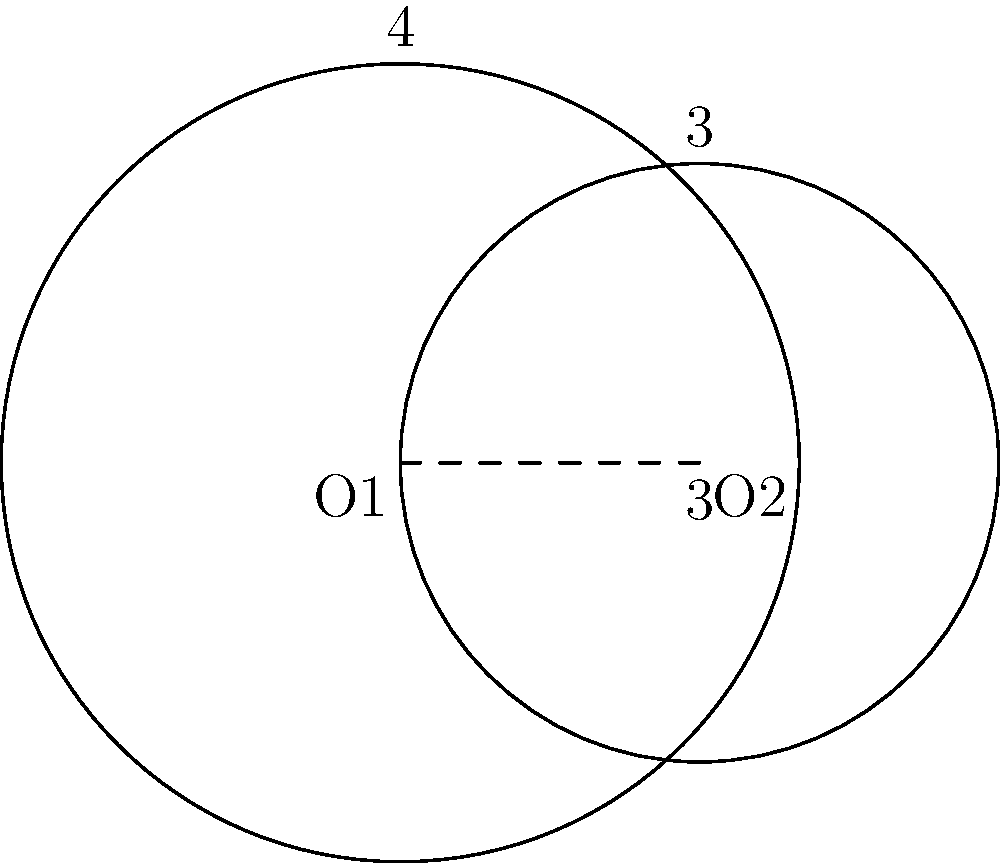As a software engineer working on a vehicle tracking system, you encounter a problem involving overlapping circular Wi-Fi ranges. Two Wi-Fi hotspots are represented by intersecting circles with centers O1 and O2. The distance between the centers is 3 units. The radius of the circle centered at O1 is 4 units, and the radius of the circle centered at O2 is 3 units. Calculate the area of the region where the two Wi-Fi ranges overlap (i.e., the area of the lens-shaped region formed by the intersection of the two circles). Let's approach this step-by-step:

1) First, we need to find the angle θ at the center of each circle in the overlapping region. We can do this using the cosine law:

   For circle O1: $\cos(\theta_1) = \frac{4^2 + 3^2 - 3^2}{2 \cdot 4 \cdot 3} = \frac{25}{24}$
   For circle O2: $\cos(\theta_2) = \frac{3^2 + 3^2 - 4^2}{2 \cdot 3 \cdot 3} = \frac{1}{6}$

2) Now, we can calculate θ1 and θ2:
   $\theta_1 = \arccos(\frac{25}{24}) \approx 0.3398$ radians
   $\theta_2 = \arccos(\frac{1}{6}) \approx 1.8235$ radians

3) The area of the lens-shaped region is the sum of two circular sectors minus the area of two triangles:

   Area = (Sector area of O1) + (Sector area of O2) - (Area of two triangles)

4) Area of sector from O1: $A_1 = \frac{1}{2} \cdot 4^2 \cdot 2\theta_1 = 8\theta_1$
   Area of sector from O2: $A_2 = \frac{1}{2} \cdot 3^2 \cdot 2\theta_2 = 9\theta_2$

5) Area of one triangle: $A_t = \frac{1}{2} \cdot 3 \cdot 4 \cdot \sin(\theta_1) = 6\sin(\theta_1)$

6) Therefore, the total area is:
   $A = 8\theta_1 + 9\theta_2 - 12\sin(\theta_1)$

7) Substituting the values:
   $A = 8 \cdot 0.3398 + 9 \cdot 1.8235 - 12 \cdot \sin(0.3398)$
   $A \approx 2.7184 + 16.4115 - 4.0164 = 15.1135$ square units
Answer: $15.1135$ square units 